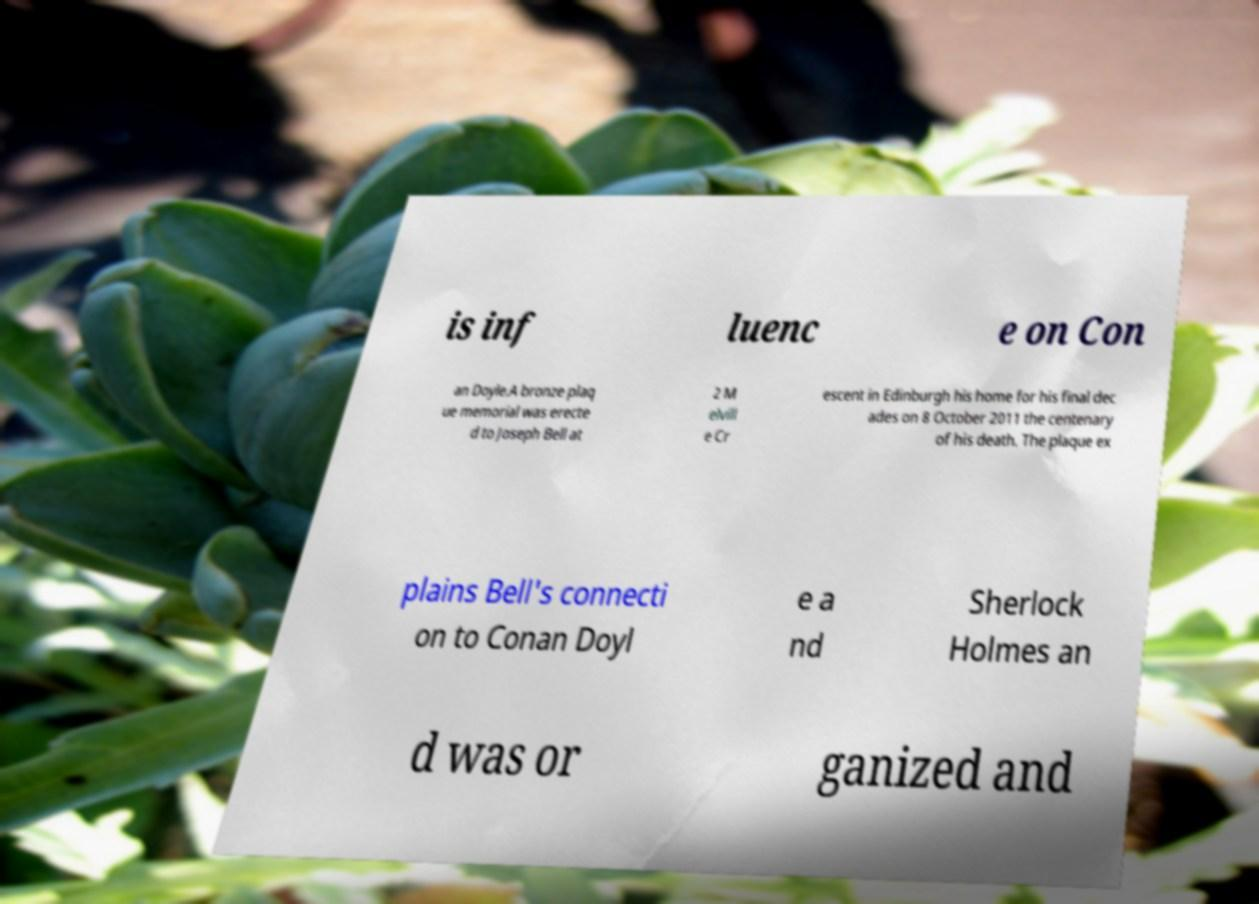Could you assist in decoding the text presented in this image and type it out clearly? is inf luenc e on Con an Doyle.A bronze plaq ue memorial was erecte d to Joseph Bell at 2 M elvill e Cr escent in Edinburgh his home for his final dec ades on 8 October 2011 the centenary of his death. The plaque ex plains Bell's connecti on to Conan Doyl e a nd Sherlock Holmes an d was or ganized and 